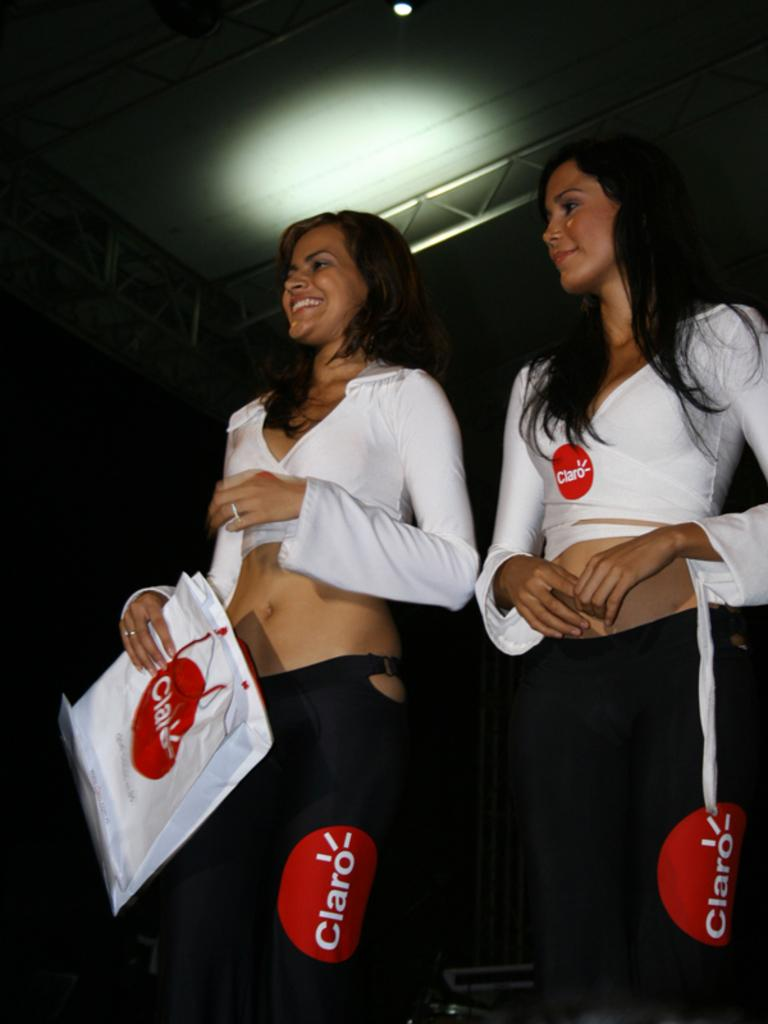<image>
Offer a succinct explanation of the picture presented. Two women dressed alike in black and white Claro attire. 